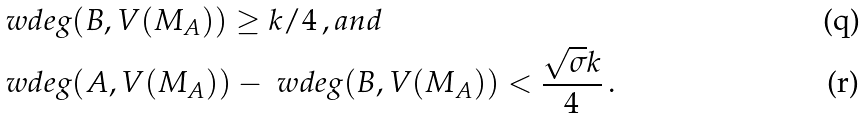Convert formula to latex. <formula><loc_0><loc_0><loc_500><loc_500>& \ w d e g ( B , V ( M _ { A } ) ) \geq k / 4 \, , a n d \\ & \ w d e g ( A , V ( M _ { A } ) ) - \ w d e g ( B , V ( M _ { A } ) ) < \frac { \sqrt { \sigma } k } 4 \, .</formula> 